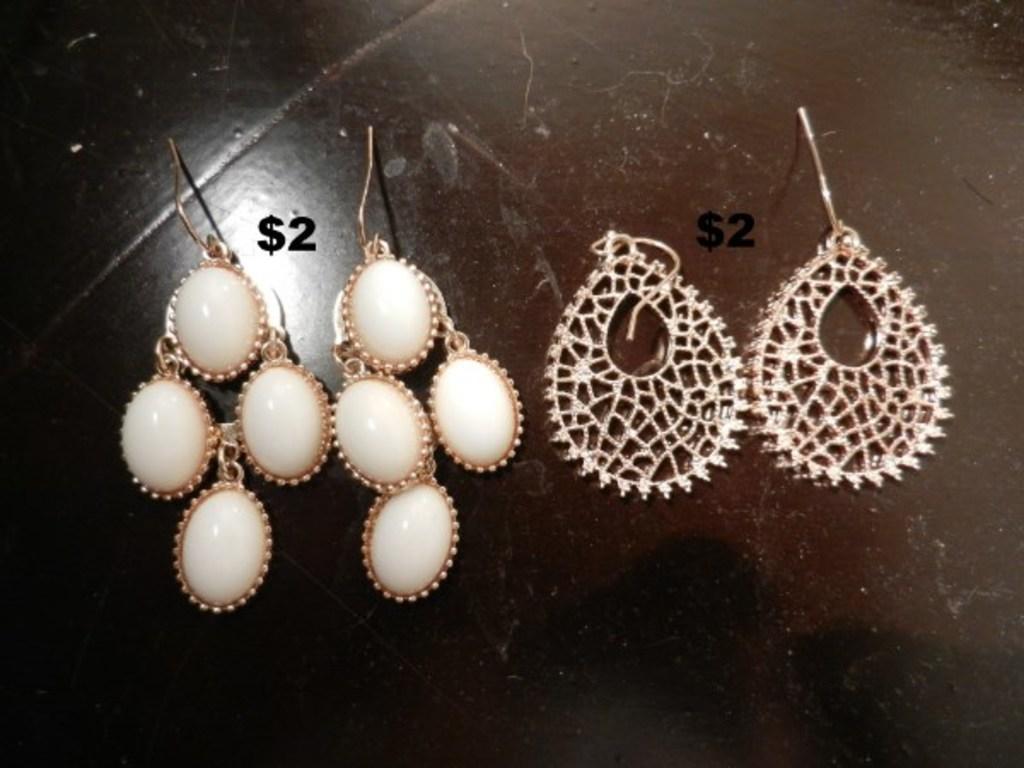Please provide a concise description of this image. Here we can see two pairs of earrings on a platform. 